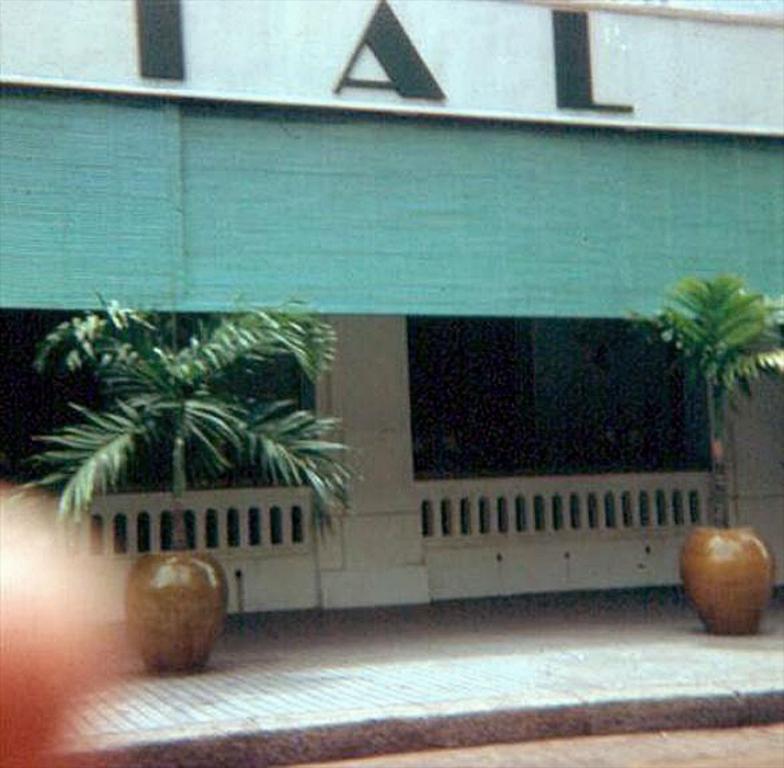Could you give a brief overview of what you see in this image? In this image I can see plant pots on the ground. In the background I can see a fence, a wall which has something written on it and a green color object. 